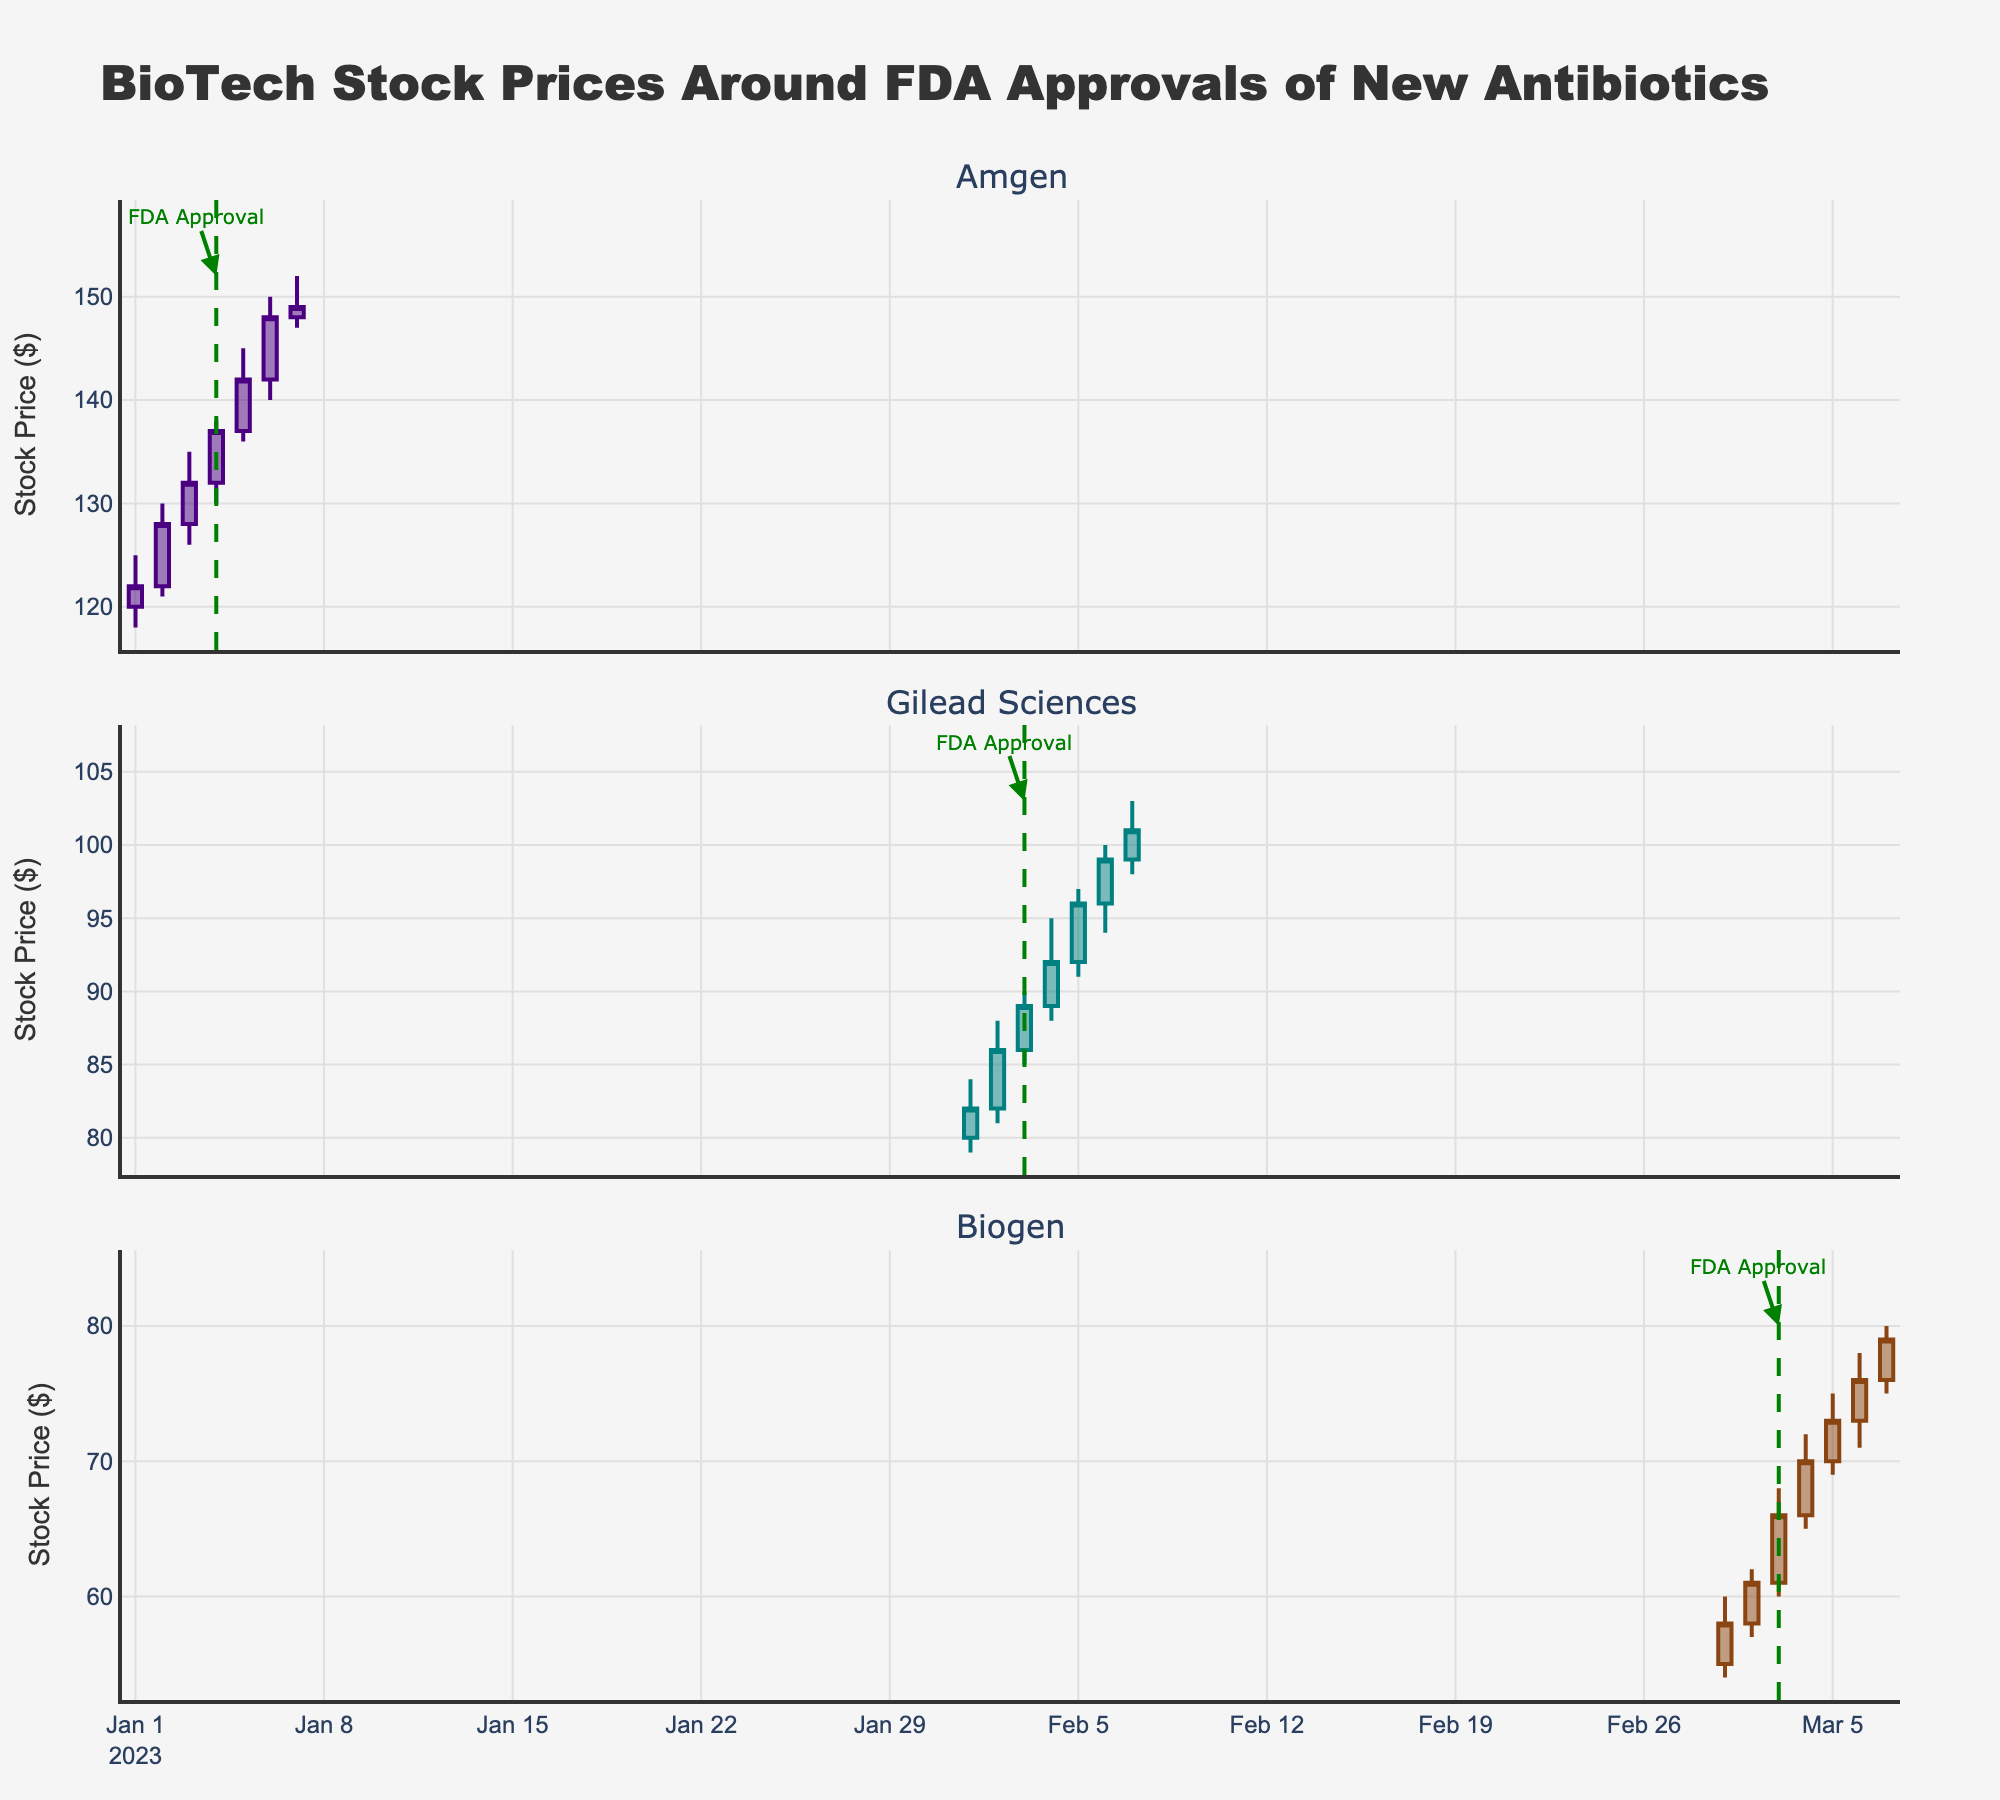What is the title of the plot? The title of the plot is located at the top and typically summarizes the content or purpose of the figure. In this case, it should reflect the focus on biotech stock prices and FDA approval events.
Answer: BioTech Stock Prices Around FDA Approvals of New Antibiotics How many companies are displayed in the figure? The figure has separate subplots for each company, easily identified by the subplot titles. Counting the titles gives the number of companies.
Answer: 3 Which company shows the highest stock price after the FDA approval? To determine this, look at the post-FDA approval period for each company and compare their highest prices. Amgen reaches $150, Gilead Sciences reaches $103, and Biogen reaches $80.
Answer: Amgen On what date does Biogen receive FDA approval for its new antibiotic? The FDA approval date for each company is marked with a vertical dashed line and an annotation. For Biogen, this line and annotation appear on the date 2023-03-03.
Answer: 2023-03-03 How did Gilead Sciences' stock price change immediately following FDA approval? Examining Gilead Sciences' subplot around the FDA approval date (2023-02-03), we see the closing prices: 89 (approval day), 92, 96, 99, and 101 on subsequent days. The price increased.
Answer: Increased What was the stock price change for Amgen from its pre-FDA approval close to its post-FDA approval close on the first day after approval? Find the closing prices just before and right after the FDA approval on the given dates. For Amgen: Pre-FDA approval (2023-01-03 closed at 132) and Post-FDA day (2023-01-05 closed at 142). The change is 142 - 132 = 10.
Answer: +10 Which company experienced the largest increase in stock price on the day of FDA approval? Compare the close prices on FDA approval day for each company. Amgen (132 to 137), Gilead Sciences (86 to 89), Biogen (61 to 66). The largest increase is for Biogen, which increased by 66 - 61 = 5.
Answer: Biogen What is the average closing price for Gilead Sciences post-FDA approval days shown in the figure? Calculate the average by summing the closing prices of the post-FDA days for Gilead Sciences (92, 96, 99, 101) and dividing by the number of days. (92 + 96 + 99 + 101) / 4 = 388 / 4 = 97
Answer: 97 What is the color of the candlestick lines for increasing prices in Amgen's subplot? The color for increasing prices for each company is specified in the code by the defined colors for each firm. For Amgen, it is set to a specific color which can be observed on the figure.
Answer: Dark purple Which company had the lowest stock price at any point in the data? To find the lowest stock price, look at the "Low" prices across all the subplots and dates. Among them, Biogen has the lowest price of $54 on 2023-03-01.
Answer: Biogen 